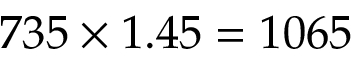Convert formula to latex. <formula><loc_0><loc_0><loc_500><loc_500>7 3 5 \times 1 . 4 5 = 1 0 6 5</formula> 